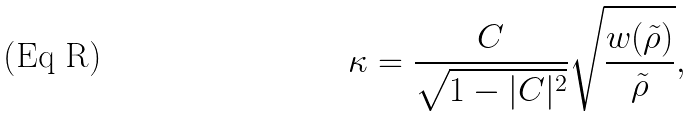<formula> <loc_0><loc_0><loc_500><loc_500>\kappa = \frac { C } { \sqrt { 1 - | C | ^ { 2 } } } \sqrt { \frac { w ( \tilde { \rho } ) } { \tilde { \rho } } } ,</formula> 